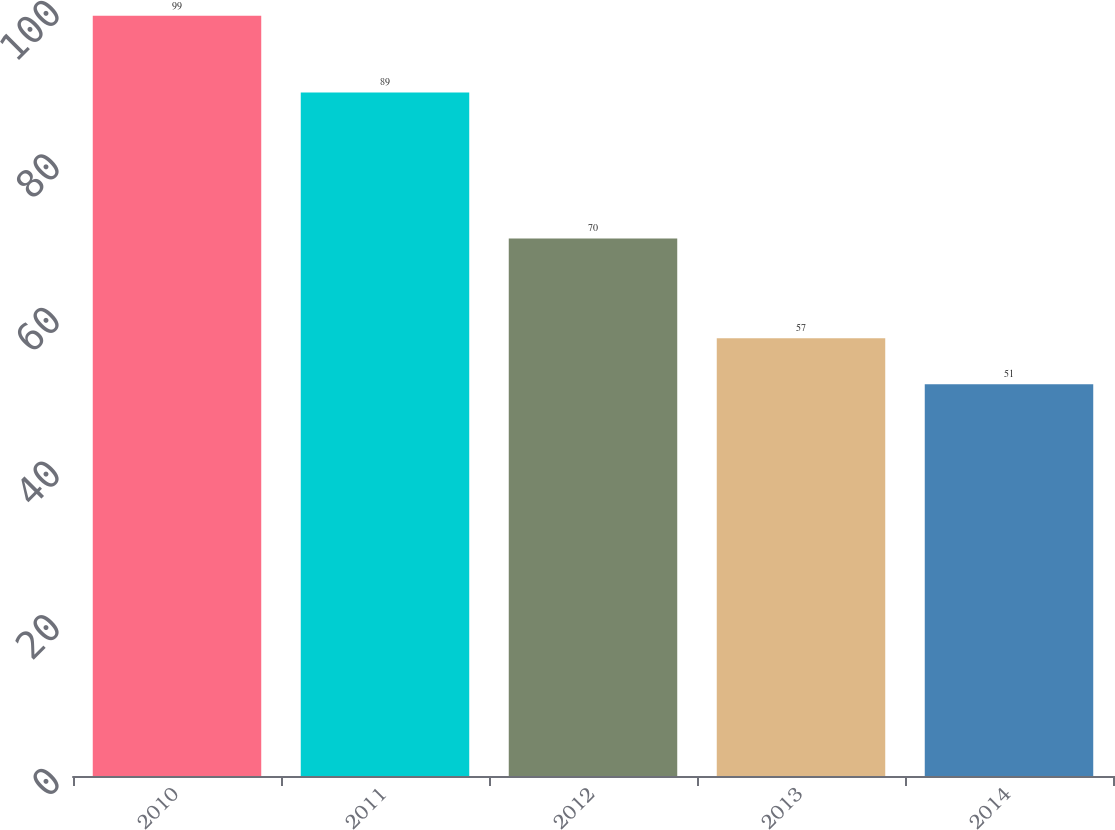<chart> <loc_0><loc_0><loc_500><loc_500><bar_chart><fcel>2010<fcel>2011<fcel>2012<fcel>2013<fcel>2014<nl><fcel>99<fcel>89<fcel>70<fcel>57<fcel>51<nl></chart> 